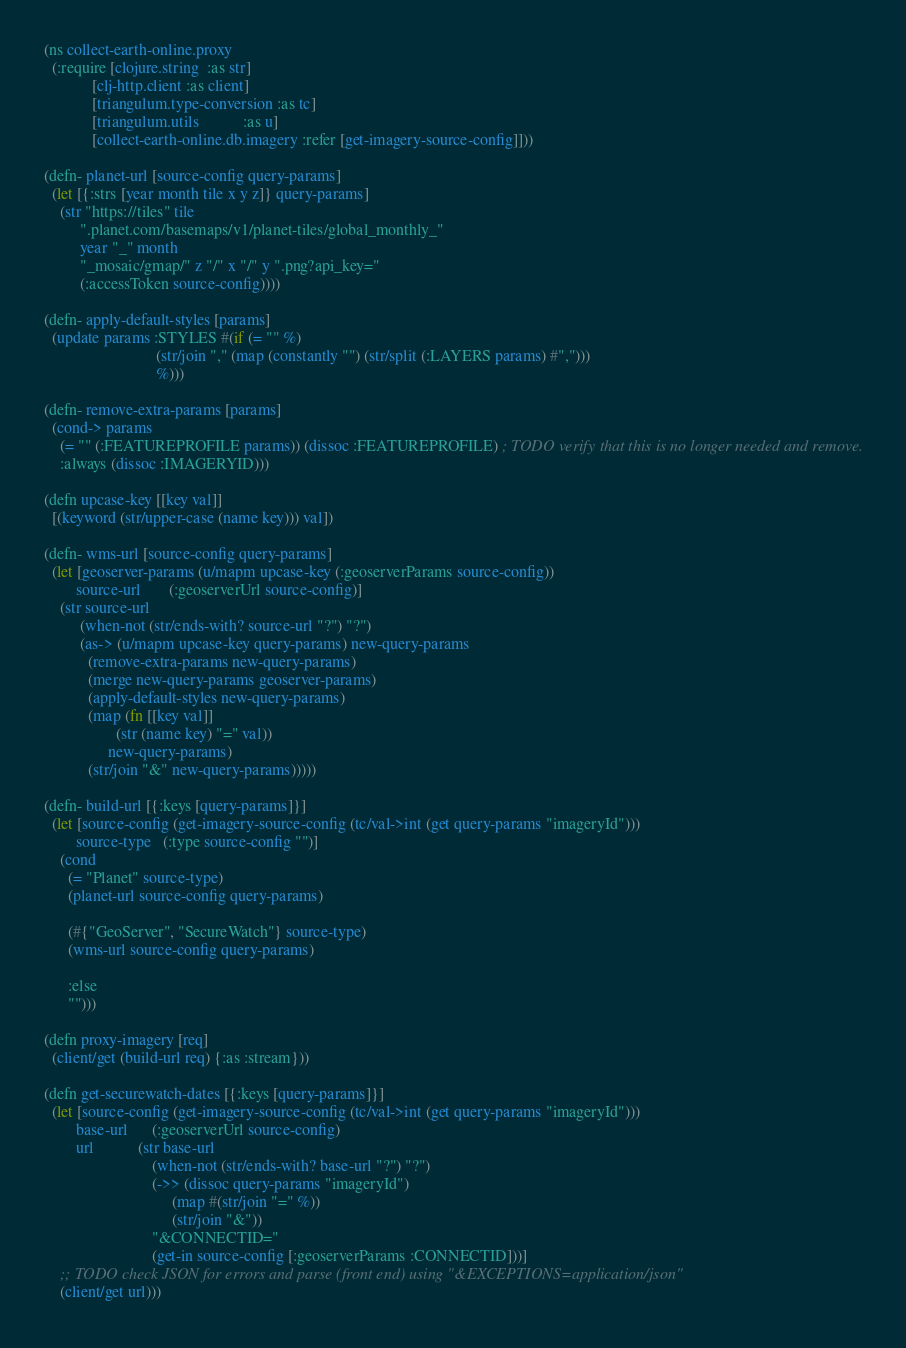<code> <loc_0><loc_0><loc_500><loc_500><_Clojure_>(ns collect-earth-online.proxy
  (:require [clojure.string  :as str]
            [clj-http.client :as client]
            [triangulum.type-conversion :as tc]
            [triangulum.utils           :as u]
            [collect-earth-online.db.imagery :refer [get-imagery-source-config]]))

(defn- planet-url [source-config query-params]
  (let [{:strs [year month tile x y z]} query-params]
    (str "https://tiles" tile
         ".planet.com/basemaps/v1/planet-tiles/global_monthly_"
         year "_" month
         "_mosaic/gmap/" z "/" x "/" y ".png?api_key="
         (:accessToken source-config))))

(defn- apply-default-styles [params]
  (update params :STYLES #(if (= "" %)
                            (str/join "," (map (constantly "") (str/split (:LAYERS params) #",")))
                            %)))

(defn- remove-extra-params [params]
  (cond-> params
    (= "" (:FEATUREPROFILE params)) (dissoc :FEATUREPROFILE) ; TODO verify that this is no longer needed and remove.
    :always (dissoc :IMAGERYID)))

(defn upcase-key [[key val]]
  [(keyword (str/upper-case (name key))) val])

(defn- wms-url [source-config query-params]
  (let [geoserver-params (u/mapm upcase-key (:geoserverParams source-config))
        source-url       (:geoserverUrl source-config)]
    (str source-url
         (when-not (str/ends-with? source-url "?") "?")
         (as-> (u/mapm upcase-key query-params) new-query-params
           (remove-extra-params new-query-params)
           (merge new-query-params geoserver-params)
           (apply-default-styles new-query-params)
           (map (fn [[key val]]
                  (str (name key) "=" val))
                new-query-params)
           (str/join "&" new-query-params)))))

(defn- build-url [{:keys [query-params]}]
  (let [source-config (get-imagery-source-config (tc/val->int (get query-params "imageryId")))
        source-type   (:type source-config "")]
    (cond
      (= "Planet" source-type)
      (planet-url source-config query-params)

      (#{"GeoServer", "SecureWatch"} source-type)
      (wms-url source-config query-params)

      :else
      "")))

(defn proxy-imagery [req]
  (client/get (build-url req) {:as :stream}))

(defn get-securewatch-dates [{:keys [query-params]}]
  (let [source-config (get-imagery-source-config (tc/val->int (get query-params "imageryId")))
        base-url      (:geoserverUrl source-config)
        url           (str base-url
                           (when-not (str/ends-with? base-url "?") "?")
                           (->> (dissoc query-params "imageryId")
                                (map #(str/join "=" %))
                                (str/join "&"))
                           "&CONNECTID="
                           (get-in source-config [:geoserverParams :CONNECTID]))]
    ;; TODO check JSON for errors and parse (front end) using "&EXCEPTIONS=application/json"
    (client/get url)))
</code> 